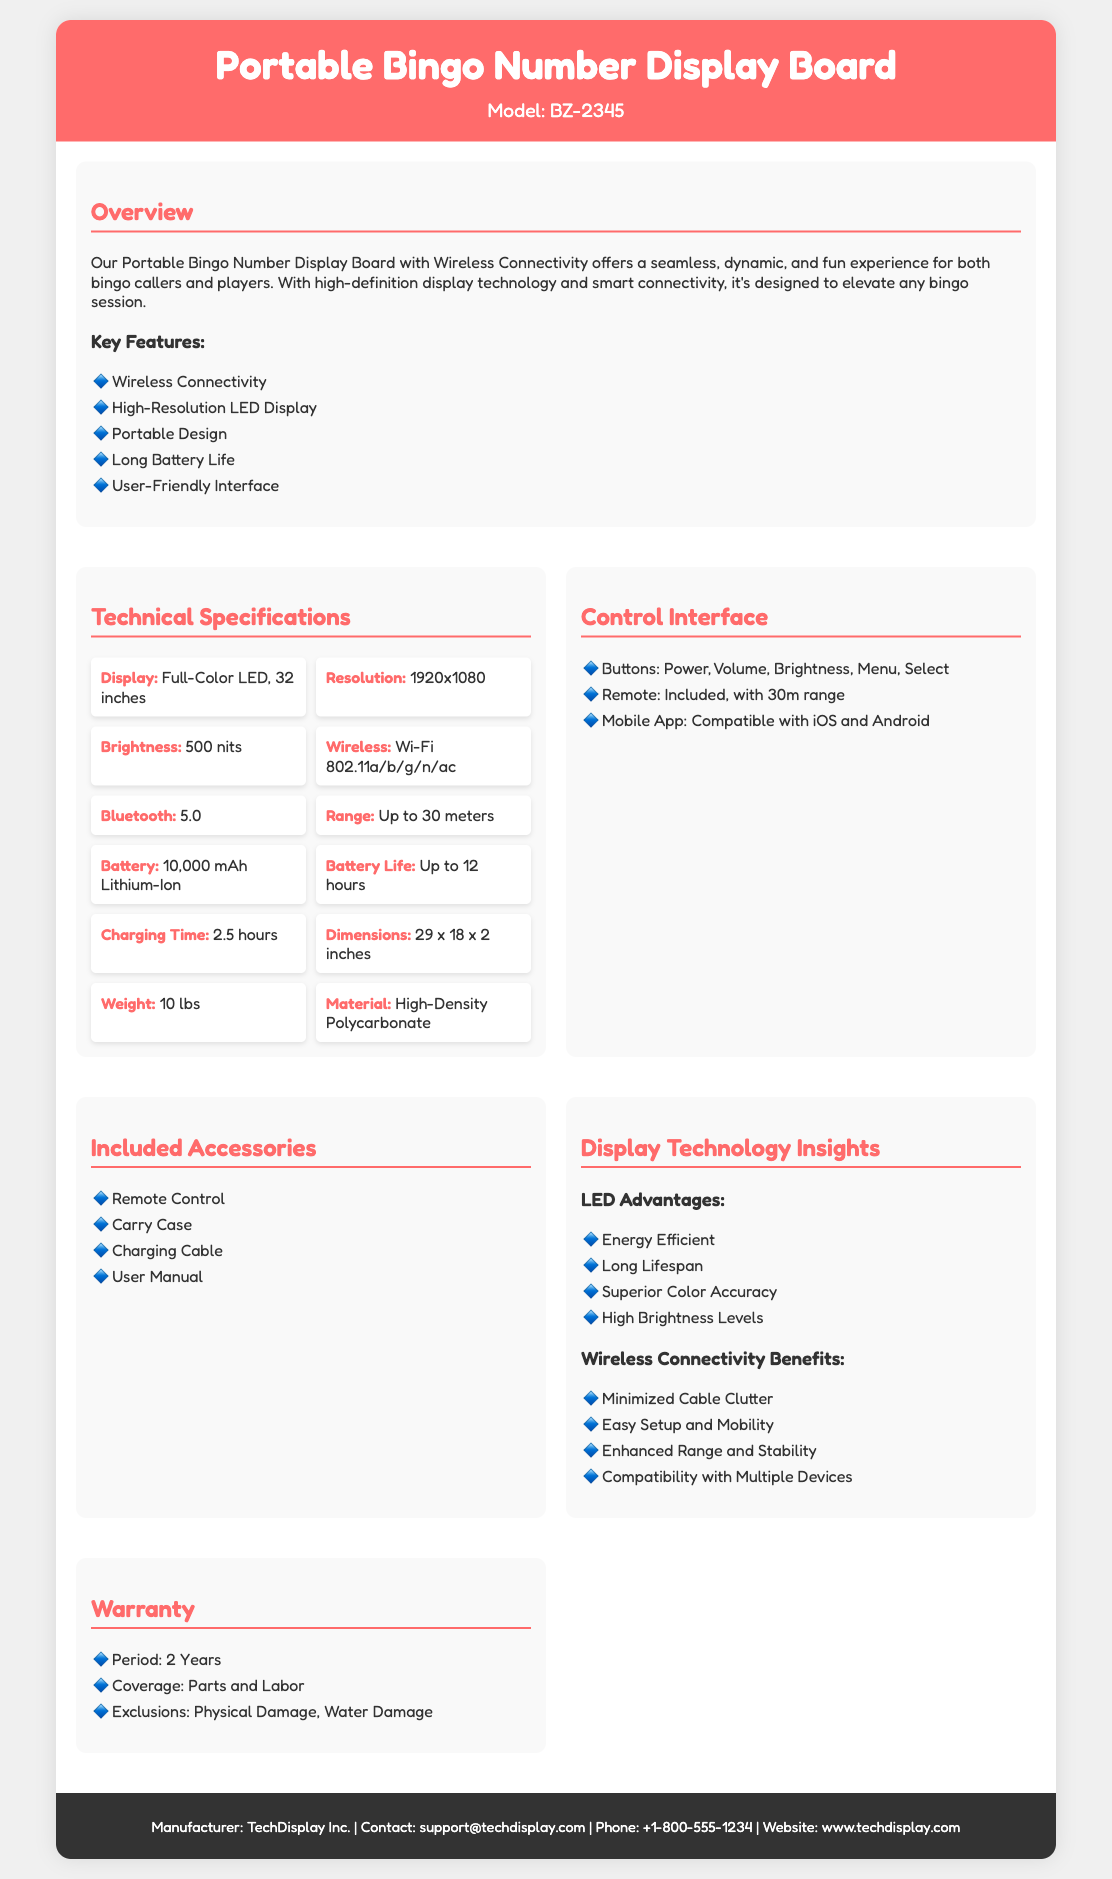What is the model name of the display board? The model name is specified in the document, indicated right below the title.
Answer: BZ-2345 What is the display size of the board? The display size is noted in the technical specifications section.
Answer: 32 inches What type of wireless connectivity does the board use? The document lists the specific wireless technology in the technical specifications.
Answer: Wi-Fi 802.11a/b/g/n/ac How long is the battery life? The battery life is clearly stated in the specifications.
Answer: Up to 12 hours What is the resolution of the display? The display resolution is mentioned in the technical specifications area.
Answer: 1920x1080 What accessory is included with the display board? The document lists several accessories in the included accessories section.
Answer: Remote Control What is a benefit of using LED technology? The document outlines advantages in the display technology insights section.
Answer: Energy Efficient What are the warranty exclusions? The warranty coverage section mentions any exclusions from the warranty.
Answer: Physical Damage, Water Damage What is the charging time for the board? The charging time is provided in the technical specifications section.
Answer: 2.5 hours 